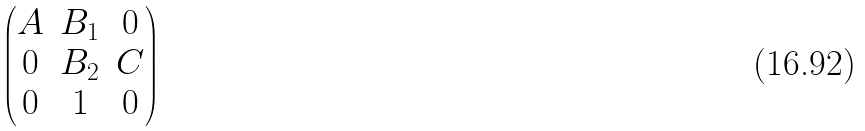Convert formula to latex. <formula><loc_0><loc_0><loc_500><loc_500>\begin{pmatrix} A & B _ { 1 } & 0 \\ 0 & B _ { 2 } & C \\ 0 & 1 & 0 \end{pmatrix}</formula> 